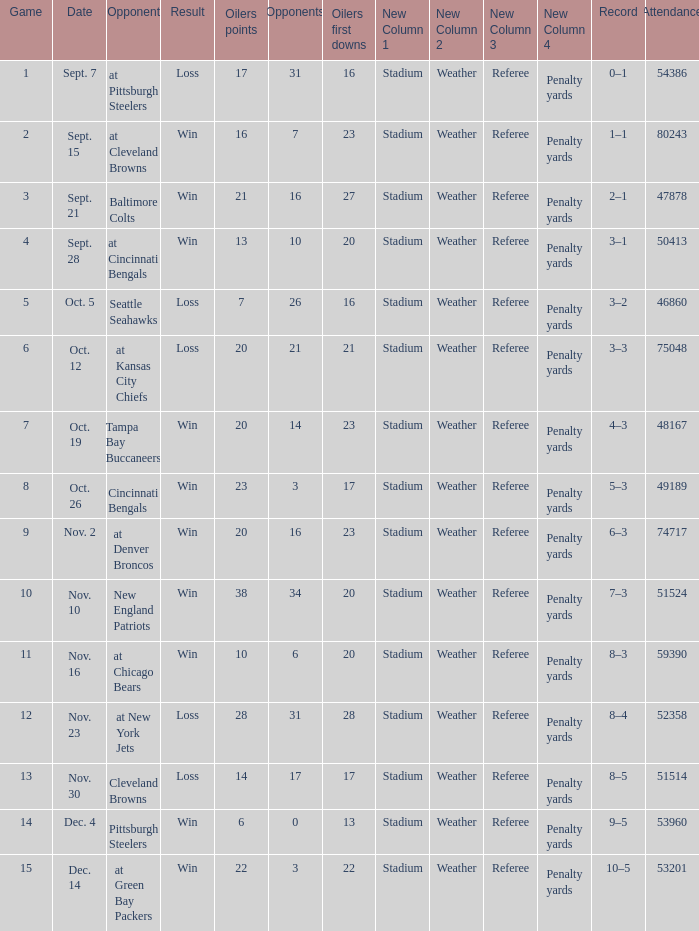What was the total opponents points for the game were the Oilers scored 21? 16.0. 